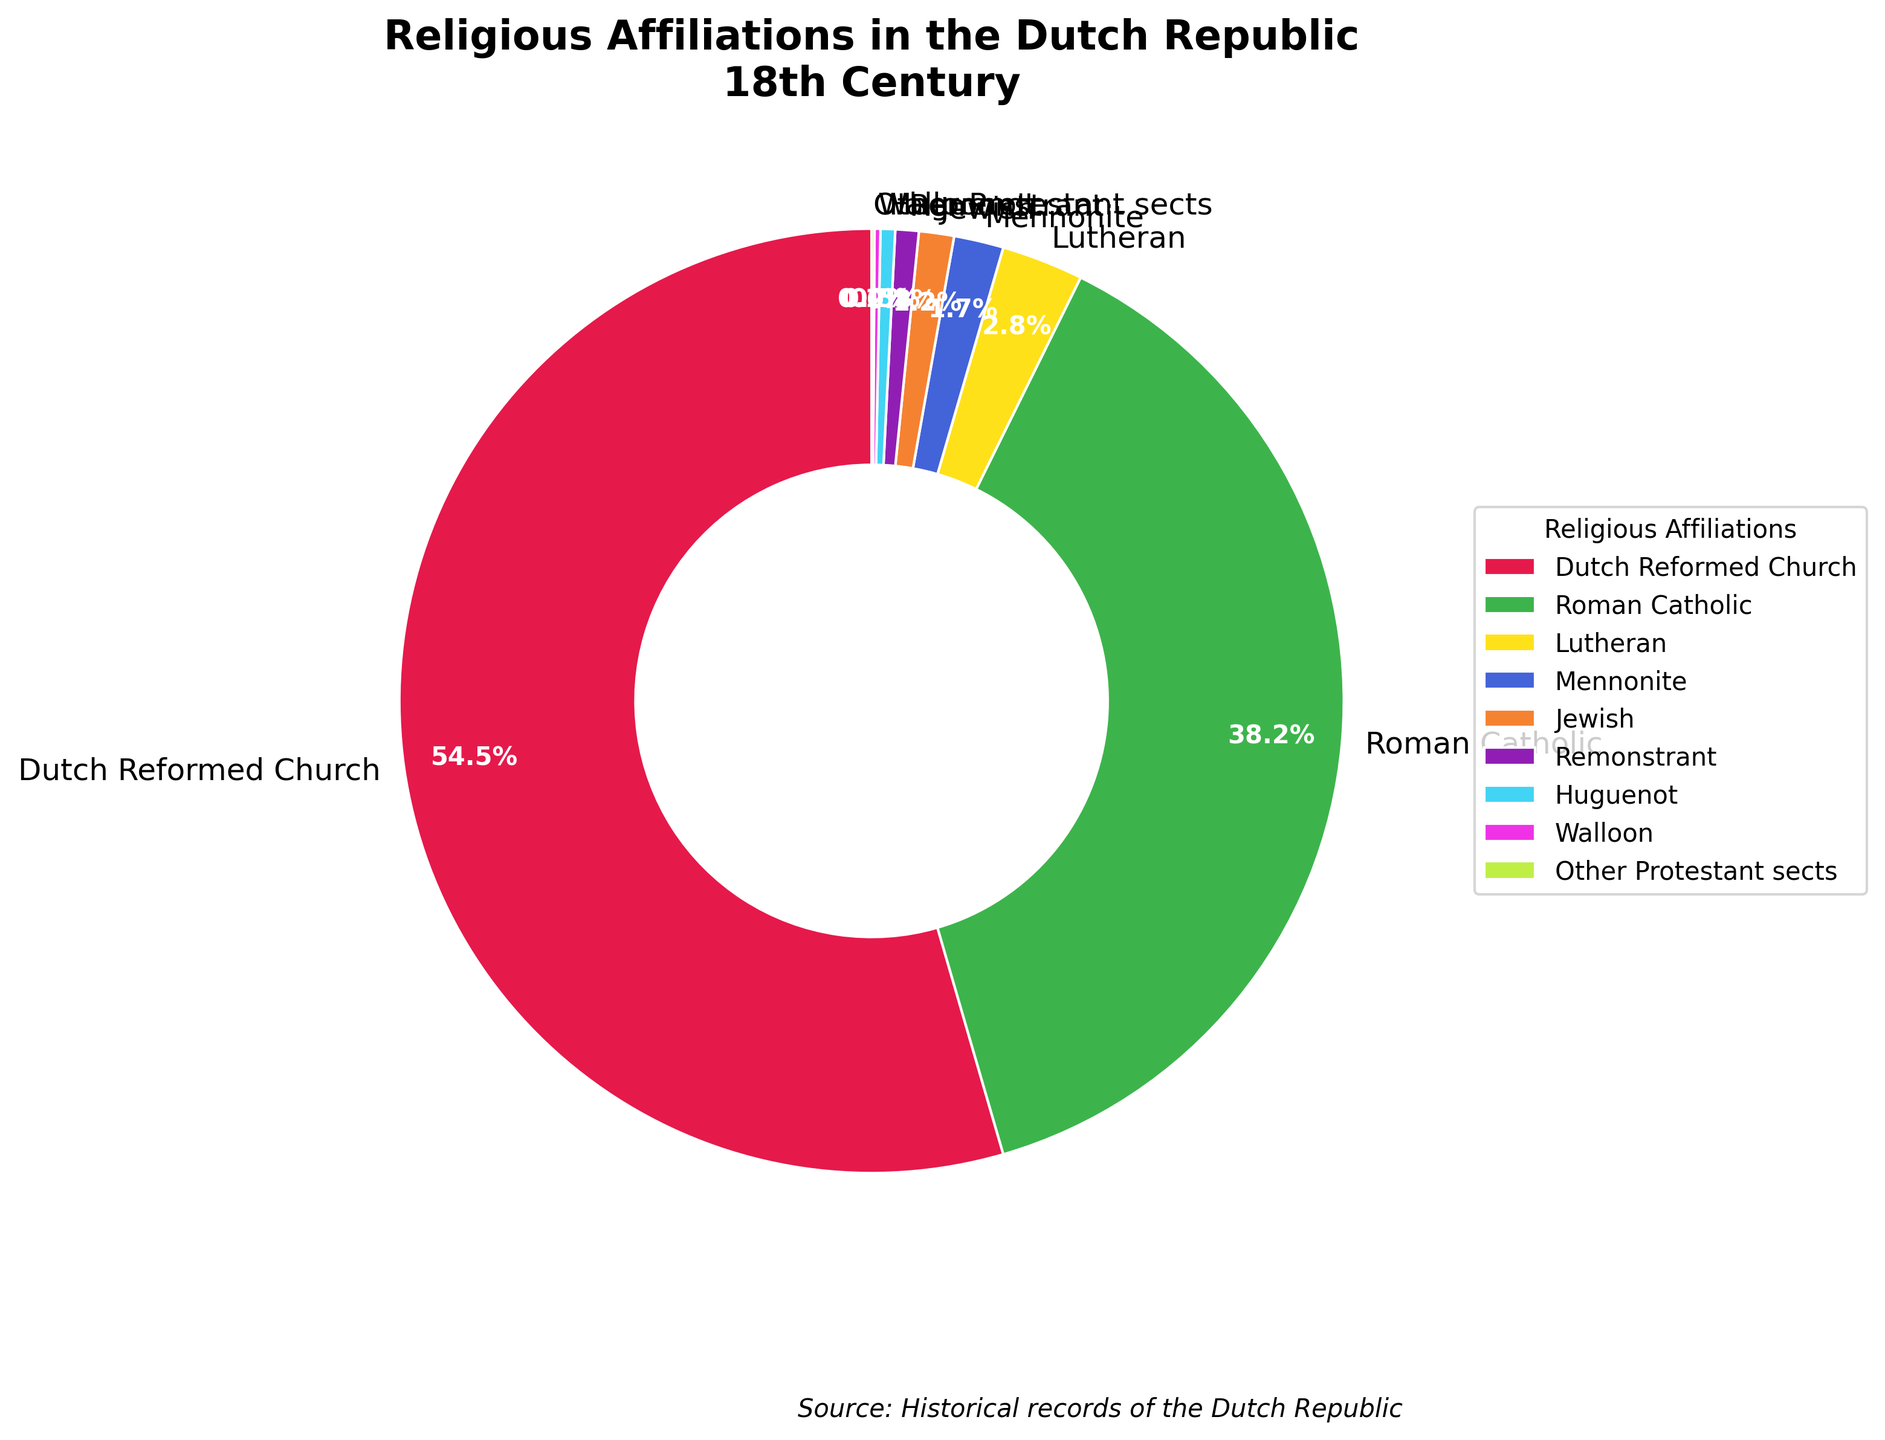What's the largest religious affiliation in the Dutch Republic during the 18th century? The chart shows different religious affiliations with corresponding percentages. The largest percentage is 54.5%, which corresponds to the Dutch Reformed Church.
Answer: Dutch Reformed Church What's the combined percentage of Mennonites and Jews? The percentages of Mennonite and Jewish are 1.7% and 1.2% respectively. Adding these together gives 1.7 + 1.2 = 2.9%.
Answer: 2.9% How does the percentage of Roman Catholics compare to that of the Dutch Reformed Church? The percentage for Roman Catholics is 38.2%, which is less than the 54.5% for the Dutch Reformed Church.
Answer: Less than Which religious affiliation has the smallest percentage, and what is it? The chart shows the smallest percentage is 0.1%, which corresponds to Other Protestant sects.
Answer: Other Protestant sects, 0.1% What is the difference in percentage between Lutherans and Huguenots? The percentage for Lutherans is 2.8% and for Huguenots is 0.5%. The difference is 2.8 - 0.5 = 2.3%.
Answer: 2.3% What percent of the population does not identify with the three major affiliations (Dutch Reformed Church, Roman Catholic, Lutheran)? The three major affiliations are Dutch Reformed Church (54.5%), Roman Catholic (38.2%), and Lutheran (2.8%). Their combined percentage is 54.5 + 38.2 + 2.8 = 95.5%. Subtracting this from 100% gives 100 - 95.5 = 4.5%.
Answer: 4.5% Name any two religious affiliations that each have less than 1% of the population. The chart shows that Remonstrants (0.8%) and Huguenots (0.5%) each have less than 1% of the population.
Answer: Remonstrant, Huguenot What's the percentage difference between Roman Catholics and all other minority affiliations combined? Roman Catholic has 38.2%. Minority affiliations combined are 2.8% (Lutheran) + 1.7% (Mennonite) + 1.2% (Jewish) + 0.8% (Remonstrant) + 0.5% (Huguenot) + 0.2% (Walloon) + 0.1% (Other Protestant sects) = 7.3%. The percentage difference is 38.2 - 7.3 = 30.9%.
Answer: 30.9% Which affiliation is visually represented by the color closest to green? Observing the visual attributes, Roman Catholic is represented by a color closest to green.
Answer: Roman Catholic 